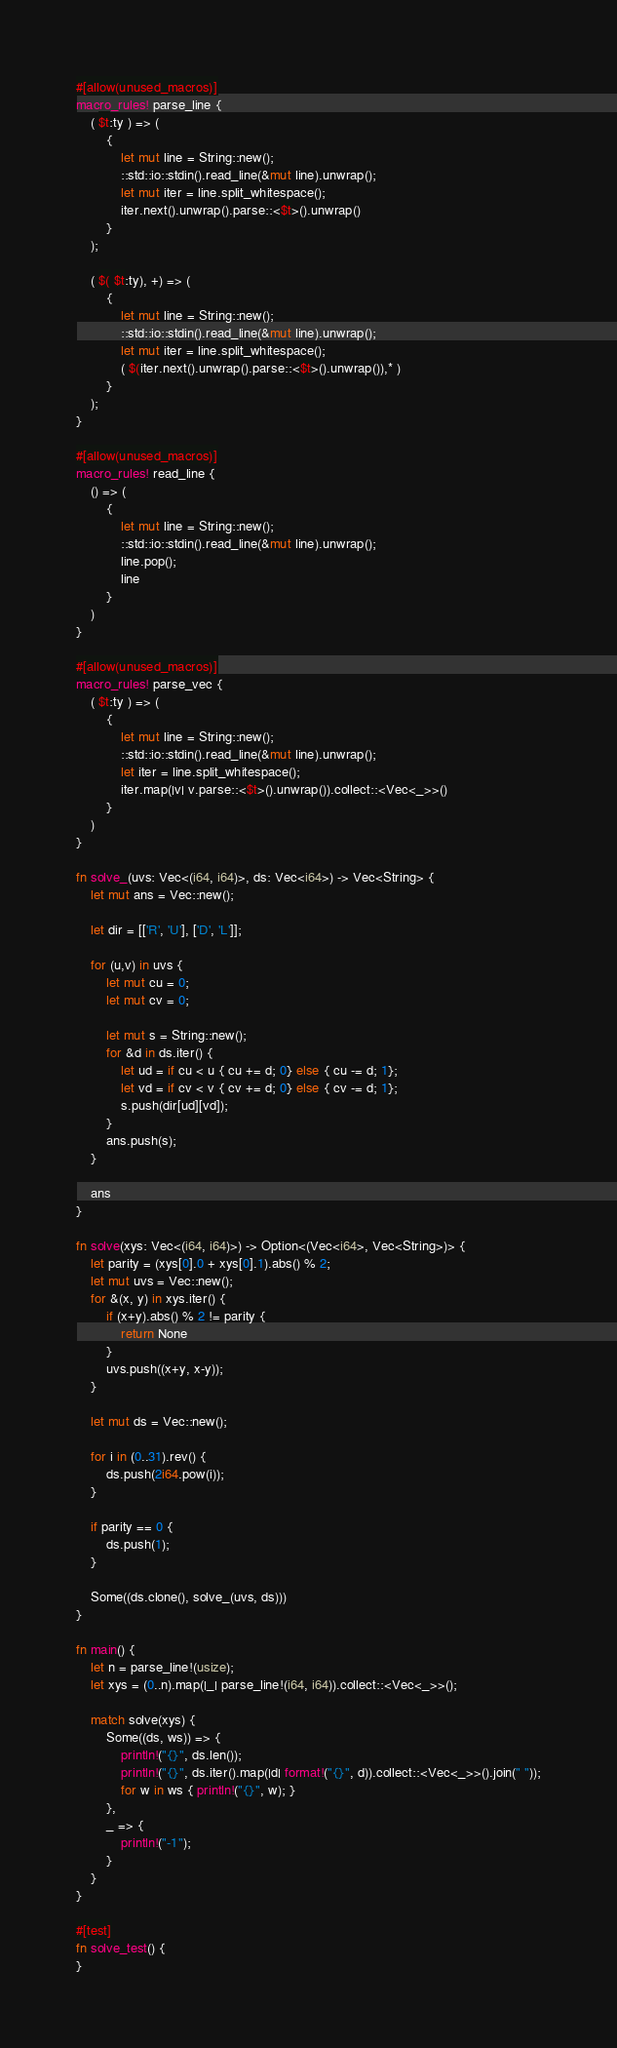Convert code to text. <code><loc_0><loc_0><loc_500><loc_500><_Rust_>#[allow(unused_macros)]
macro_rules! parse_line {
    ( $t:ty ) => (
        {
            let mut line = String::new();
            ::std::io::stdin().read_line(&mut line).unwrap();
            let mut iter = line.split_whitespace();
            iter.next().unwrap().parse::<$t>().unwrap()
        }
    );

    ( $( $t:ty), +) => (
        {
            let mut line = String::new();
            ::std::io::stdin().read_line(&mut line).unwrap();
            let mut iter = line.split_whitespace();
            ( $(iter.next().unwrap().parse::<$t>().unwrap()),* )
        }
    );
}

#[allow(unused_macros)]
macro_rules! read_line {
    () => (
        {
            let mut line = String::new();
            ::std::io::stdin().read_line(&mut line).unwrap();
            line.pop();
            line
        }
    )
}

#[allow(unused_macros)]
macro_rules! parse_vec {
    ( $t:ty ) => (
        {
            let mut line = String::new();
            ::std::io::stdin().read_line(&mut line).unwrap();
            let iter = line.split_whitespace();
            iter.map(|v| v.parse::<$t>().unwrap()).collect::<Vec<_>>()
        }
    )
}

fn solve_(uvs: Vec<(i64, i64)>, ds: Vec<i64>) -> Vec<String> {
    let mut ans = Vec::new();

    let dir = [['R', 'U'], ['D', 'L']];

    for (u,v) in uvs {
        let mut cu = 0;
        let mut cv = 0;

        let mut s = String::new();
        for &d in ds.iter() {
            let ud = if cu < u { cu += d; 0} else { cu -= d; 1};
            let vd = if cv < v { cv += d; 0} else { cv -= d; 1};
            s.push(dir[ud][vd]);
        }
        ans.push(s);
    }

    ans
}

fn solve(xys: Vec<(i64, i64)>) -> Option<(Vec<i64>, Vec<String>)> {
    let parity = (xys[0].0 + xys[0].1).abs() % 2;
    let mut uvs = Vec::new();
    for &(x, y) in xys.iter() {
        if (x+y).abs() % 2 != parity {
            return None
        }
        uvs.push((x+y, x-y));
    }

    let mut ds = Vec::new();

    for i in (0..31).rev() {
        ds.push(2i64.pow(i));
    }

    if parity == 0 {
        ds.push(1);
    }

    Some((ds.clone(), solve_(uvs, ds)))
}

fn main() {
    let n = parse_line!(usize);
    let xys = (0..n).map(|_| parse_line!(i64, i64)).collect::<Vec<_>>();

    match solve(xys) {
        Some((ds, ws)) => {
            println!("{}", ds.len());
            println!("{}", ds.iter().map(|d| format!("{}", d)).collect::<Vec<_>>().join(" "));
            for w in ws { println!("{}", w); }
        },
        _ => {
            println!("-1");
        }
    }
}

#[test]
fn solve_test() {
}
</code> 